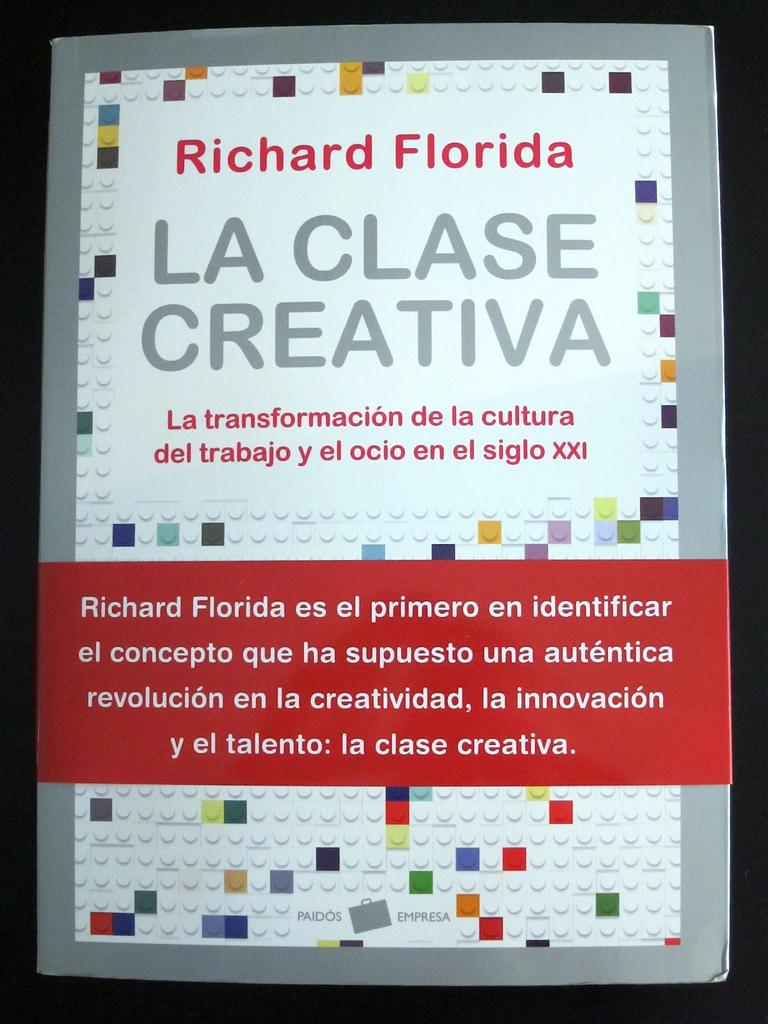Provide a one-sentence caption for the provided image. A notice about Richard Florida is written in Spanish. 